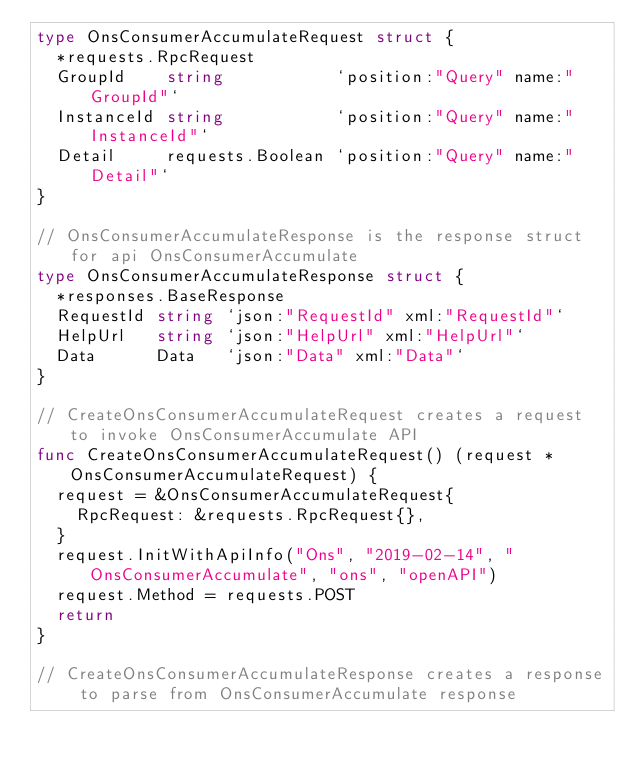Convert code to text. <code><loc_0><loc_0><loc_500><loc_500><_Go_>type OnsConsumerAccumulateRequest struct {
	*requests.RpcRequest
	GroupId    string           `position:"Query" name:"GroupId"`
	InstanceId string           `position:"Query" name:"InstanceId"`
	Detail     requests.Boolean `position:"Query" name:"Detail"`
}

// OnsConsumerAccumulateResponse is the response struct for api OnsConsumerAccumulate
type OnsConsumerAccumulateResponse struct {
	*responses.BaseResponse
	RequestId string `json:"RequestId" xml:"RequestId"`
	HelpUrl   string `json:"HelpUrl" xml:"HelpUrl"`
	Data      Data   `json:"Data" xml:"Data"`
}

// CreateOnsConsumerAccumulateRequest creates a request to invoke OnsConsumerAccumulate API
func CreateOnsConsumerAccumulateRequest() (request *OnsConsumerAccumulateRequest) {
	request = &OnsConsumerAccumulateRequest{
		RpcRequest: &requests.RpcRequest{},
	}
	request.InitWithApiInfo("Ons", "2019-02-14", "OnsConsumerAccumulate", "ons", "openAPI")
	request.Method = requests.POST
	return
}

// CreateOnsConsumerAccumulateResponse creates a response to parse from OnsConsumerAccumulate response</code> 